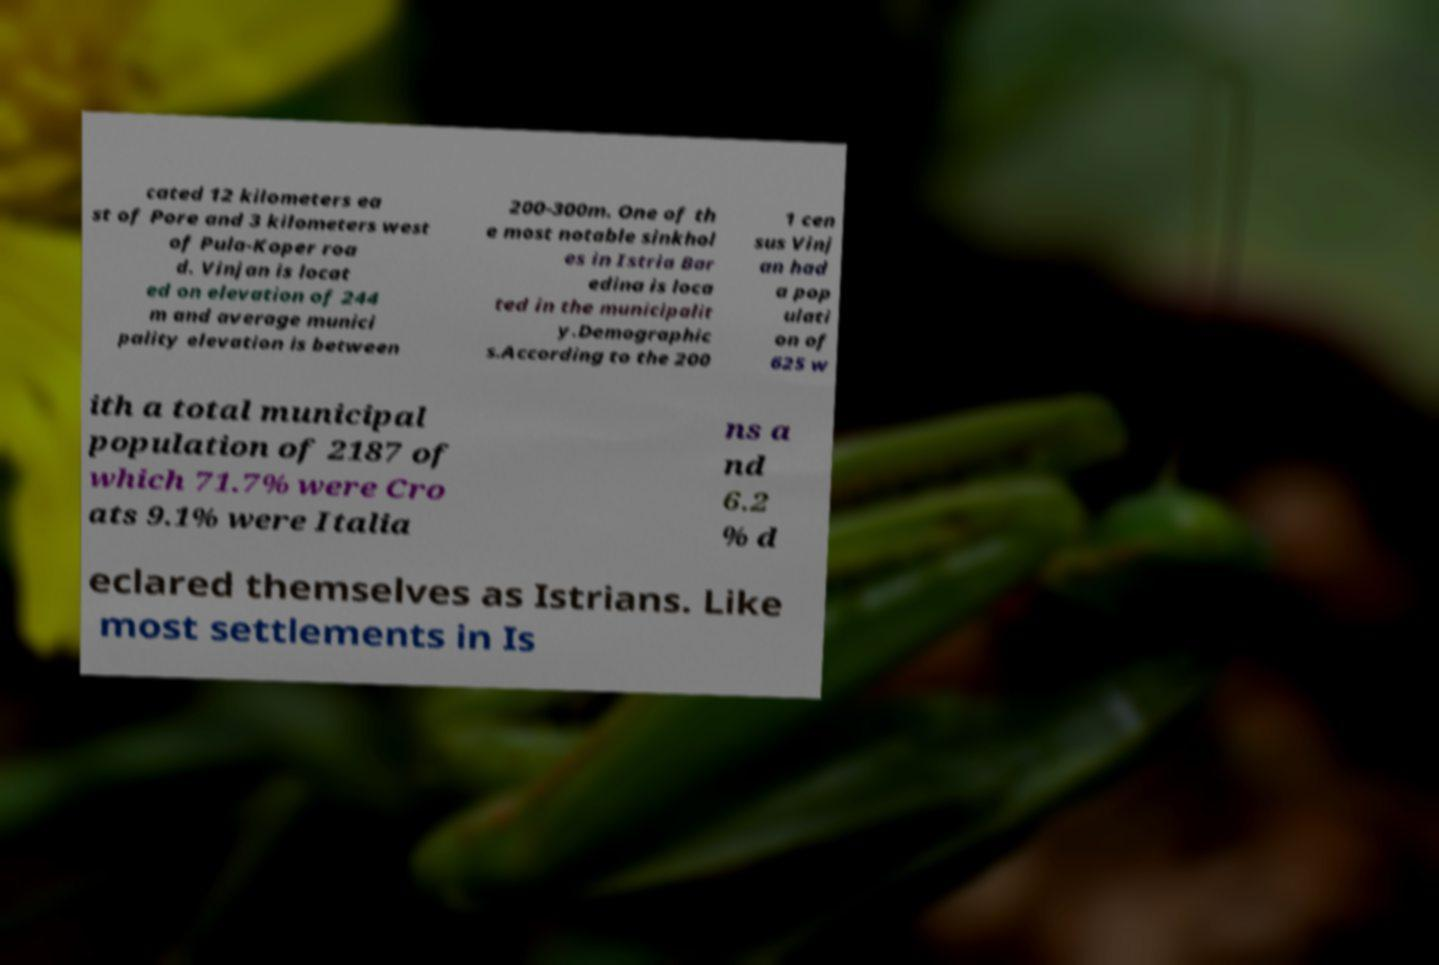What messages or text are displayed in this image? I need them in a readable, typed format. cated 12 kilometers ea st of Pore and 3 kilometers west of Pula-Koper roa d. Vinjan is locat ed on elevation of 244 m and average munici pality elevation is between 200-300m. One of th e most notable sinkhol es in Istria Bar edina is loca ted in the municipalit y.Demographic s.According to the 200 1 cen sus Vinj an had a pop ulati on of 625 w ith a total municipal population of 2187 of which 71.7% were Cro ats 9.1% were Italia ns a nd 6.2 % d eclared themselves as Istrians. Like most settlements in Is 